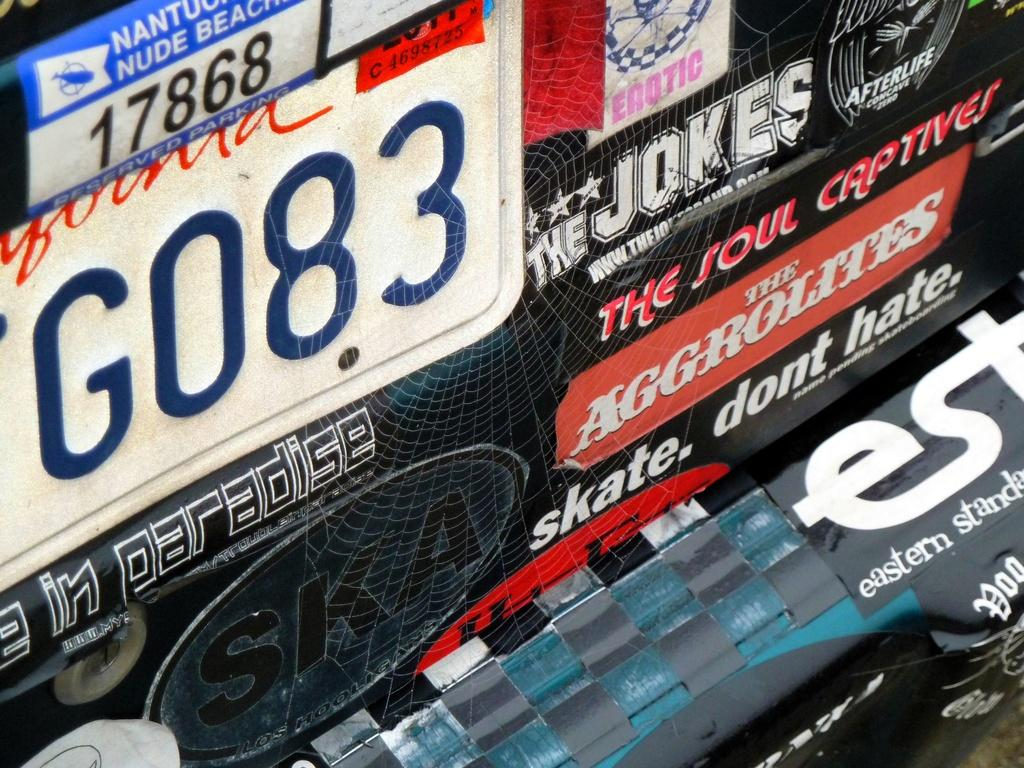What is the focus of the image? The image is zoomed in, so the focus is on a specific area or object. What can be seen in the foreground of the image? There are boards in the foreground, and text and numbers are printed on some of them. What is a notable feature visible in the image? A spider web is visible in the image. What type of father is depicted in the image? There is no father present in the image; it features boards, text, numbers, and a spider web. How does the beggar interact with the objects in the image? There is no beggar present in the image; it only contains boards, text, numbers, and a spider web. 